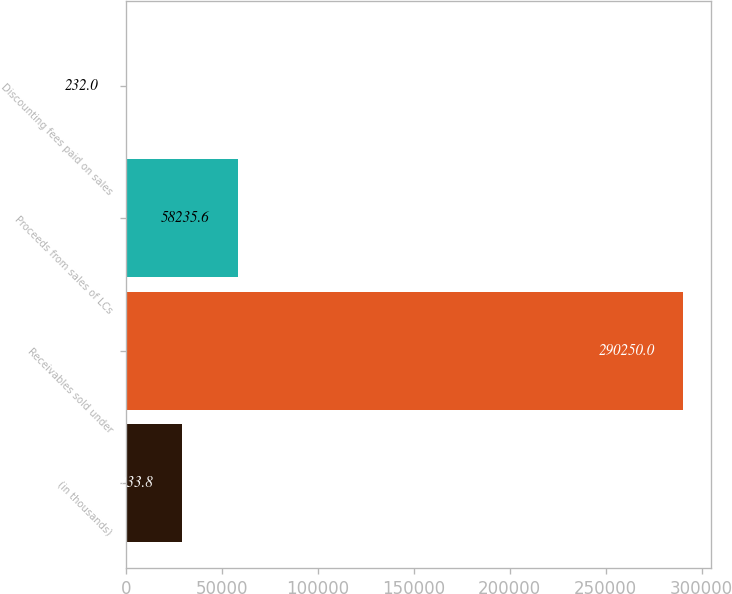Convert chart to OTSL. <chart><loc_0><loc_0><loc_500><loc_500><bar_chart><fcel>(in thousands)<fcel>Receivables sold under<fcel>Proceeds from sales of LCs<fcel>Discounting fees paid on sales<nl><fcel>29233.8<fcel>290250<fcel>58235.6<fcel>232<nl></chart> 